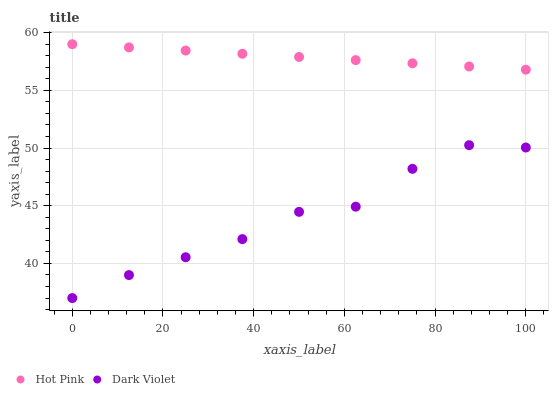Does Dark Violet have the minimum area under the curve?
Answer yes or no. Yes. Does Hot Pink have the maximum area under the curve?
Answer yes or no. Yes. Does Dark Violet have the maximum area under the curve?
Answer yes or no. No. Is Hot Pink the smoothest?
Answer yes or no. Yes. Is Dark Violet the roughest?
Answer yes or no. Yes. Is Dark Violet the smoothest?
Answer yes or no. No. Does Dark Violet have the lowest value?
Answer yes or no. Yes. Does Hot Pink have the highest value?
Answer yes or no. Yes. Does Dark Violet have the highest value?
Answer yes or no. No. Is Dark Violet less than Hot Pink?
Answer yes or no. Yes. Is Hot Pink greater than Dark Violet?
Answer yes or no. Yes. Does Dark Violet intersect Hot Pink?
Answer yes or no. No. 